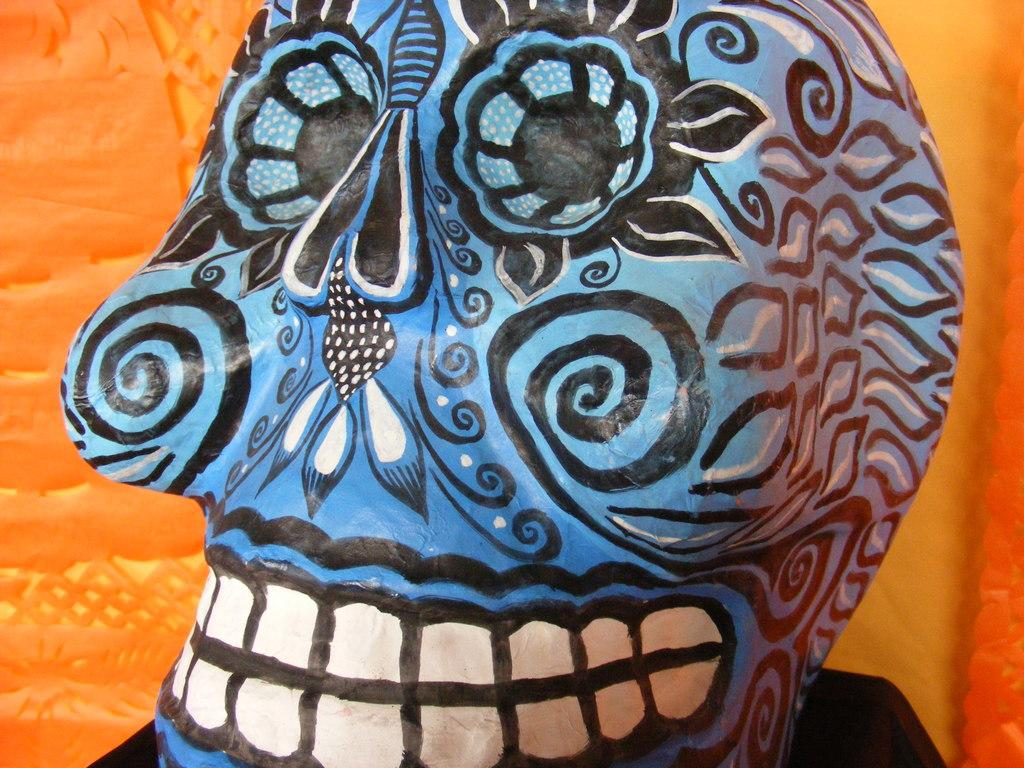What is the main subject of the image? The main subject of the image is a dead mask. What can be observed about the background of the image? The background color of the image is orange. How many suits are hanging in the image? There are no suits present in the image; it features a dead mask against an orange background. How many bikes are visible in the image? There are no bikes present in the image; it features a dead mask against an orange background. 